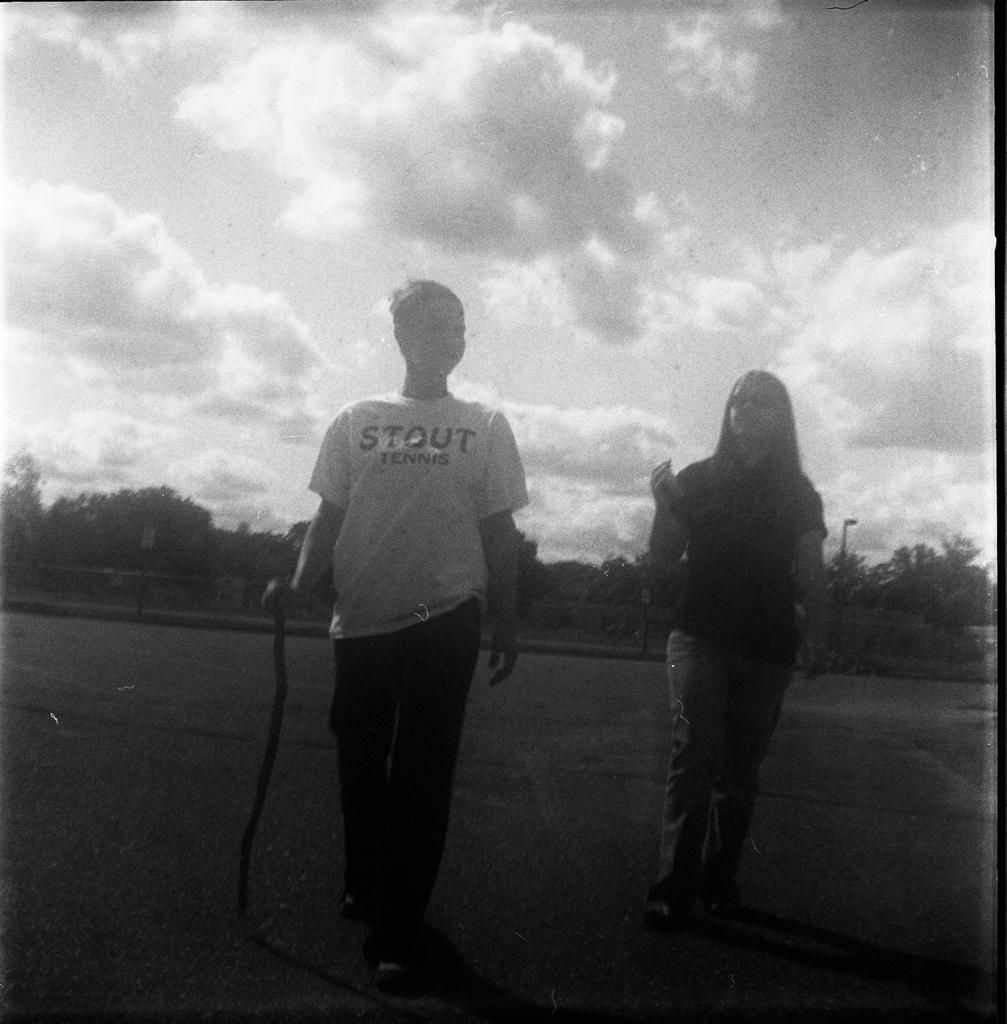In one or two sentences, can you explain what this image depicts? There is a person holding a stick. Behind the person there is a woman wearing a goggles. Both are walking. In the background there is sky and trees. 